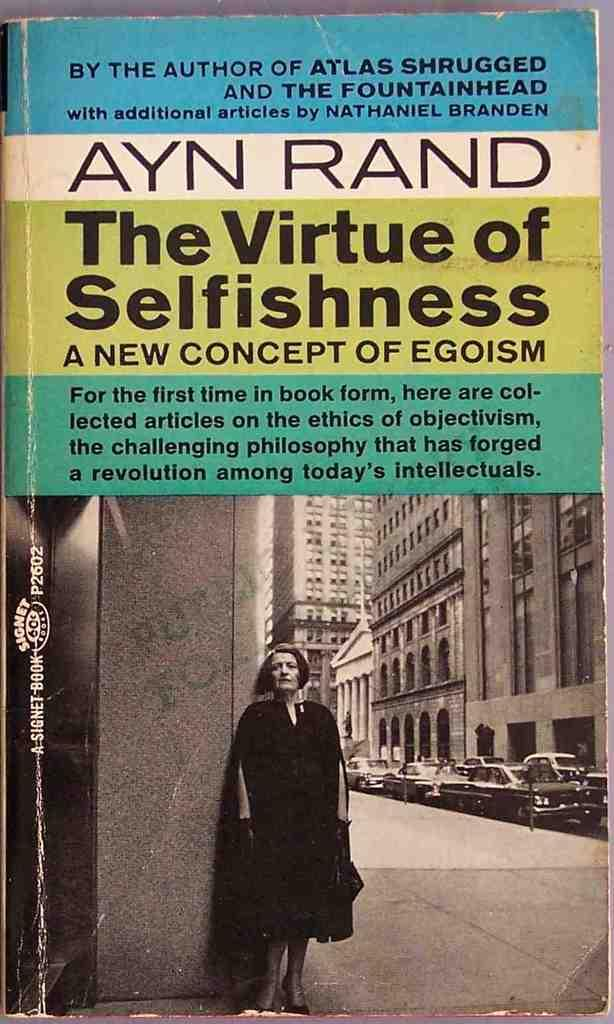<image>
Create a compact narrative representing the image presented. The book cover of "The Virtue of Selfishness" by Ayn Rand shows a black and white picture of a lady standing on a street. 